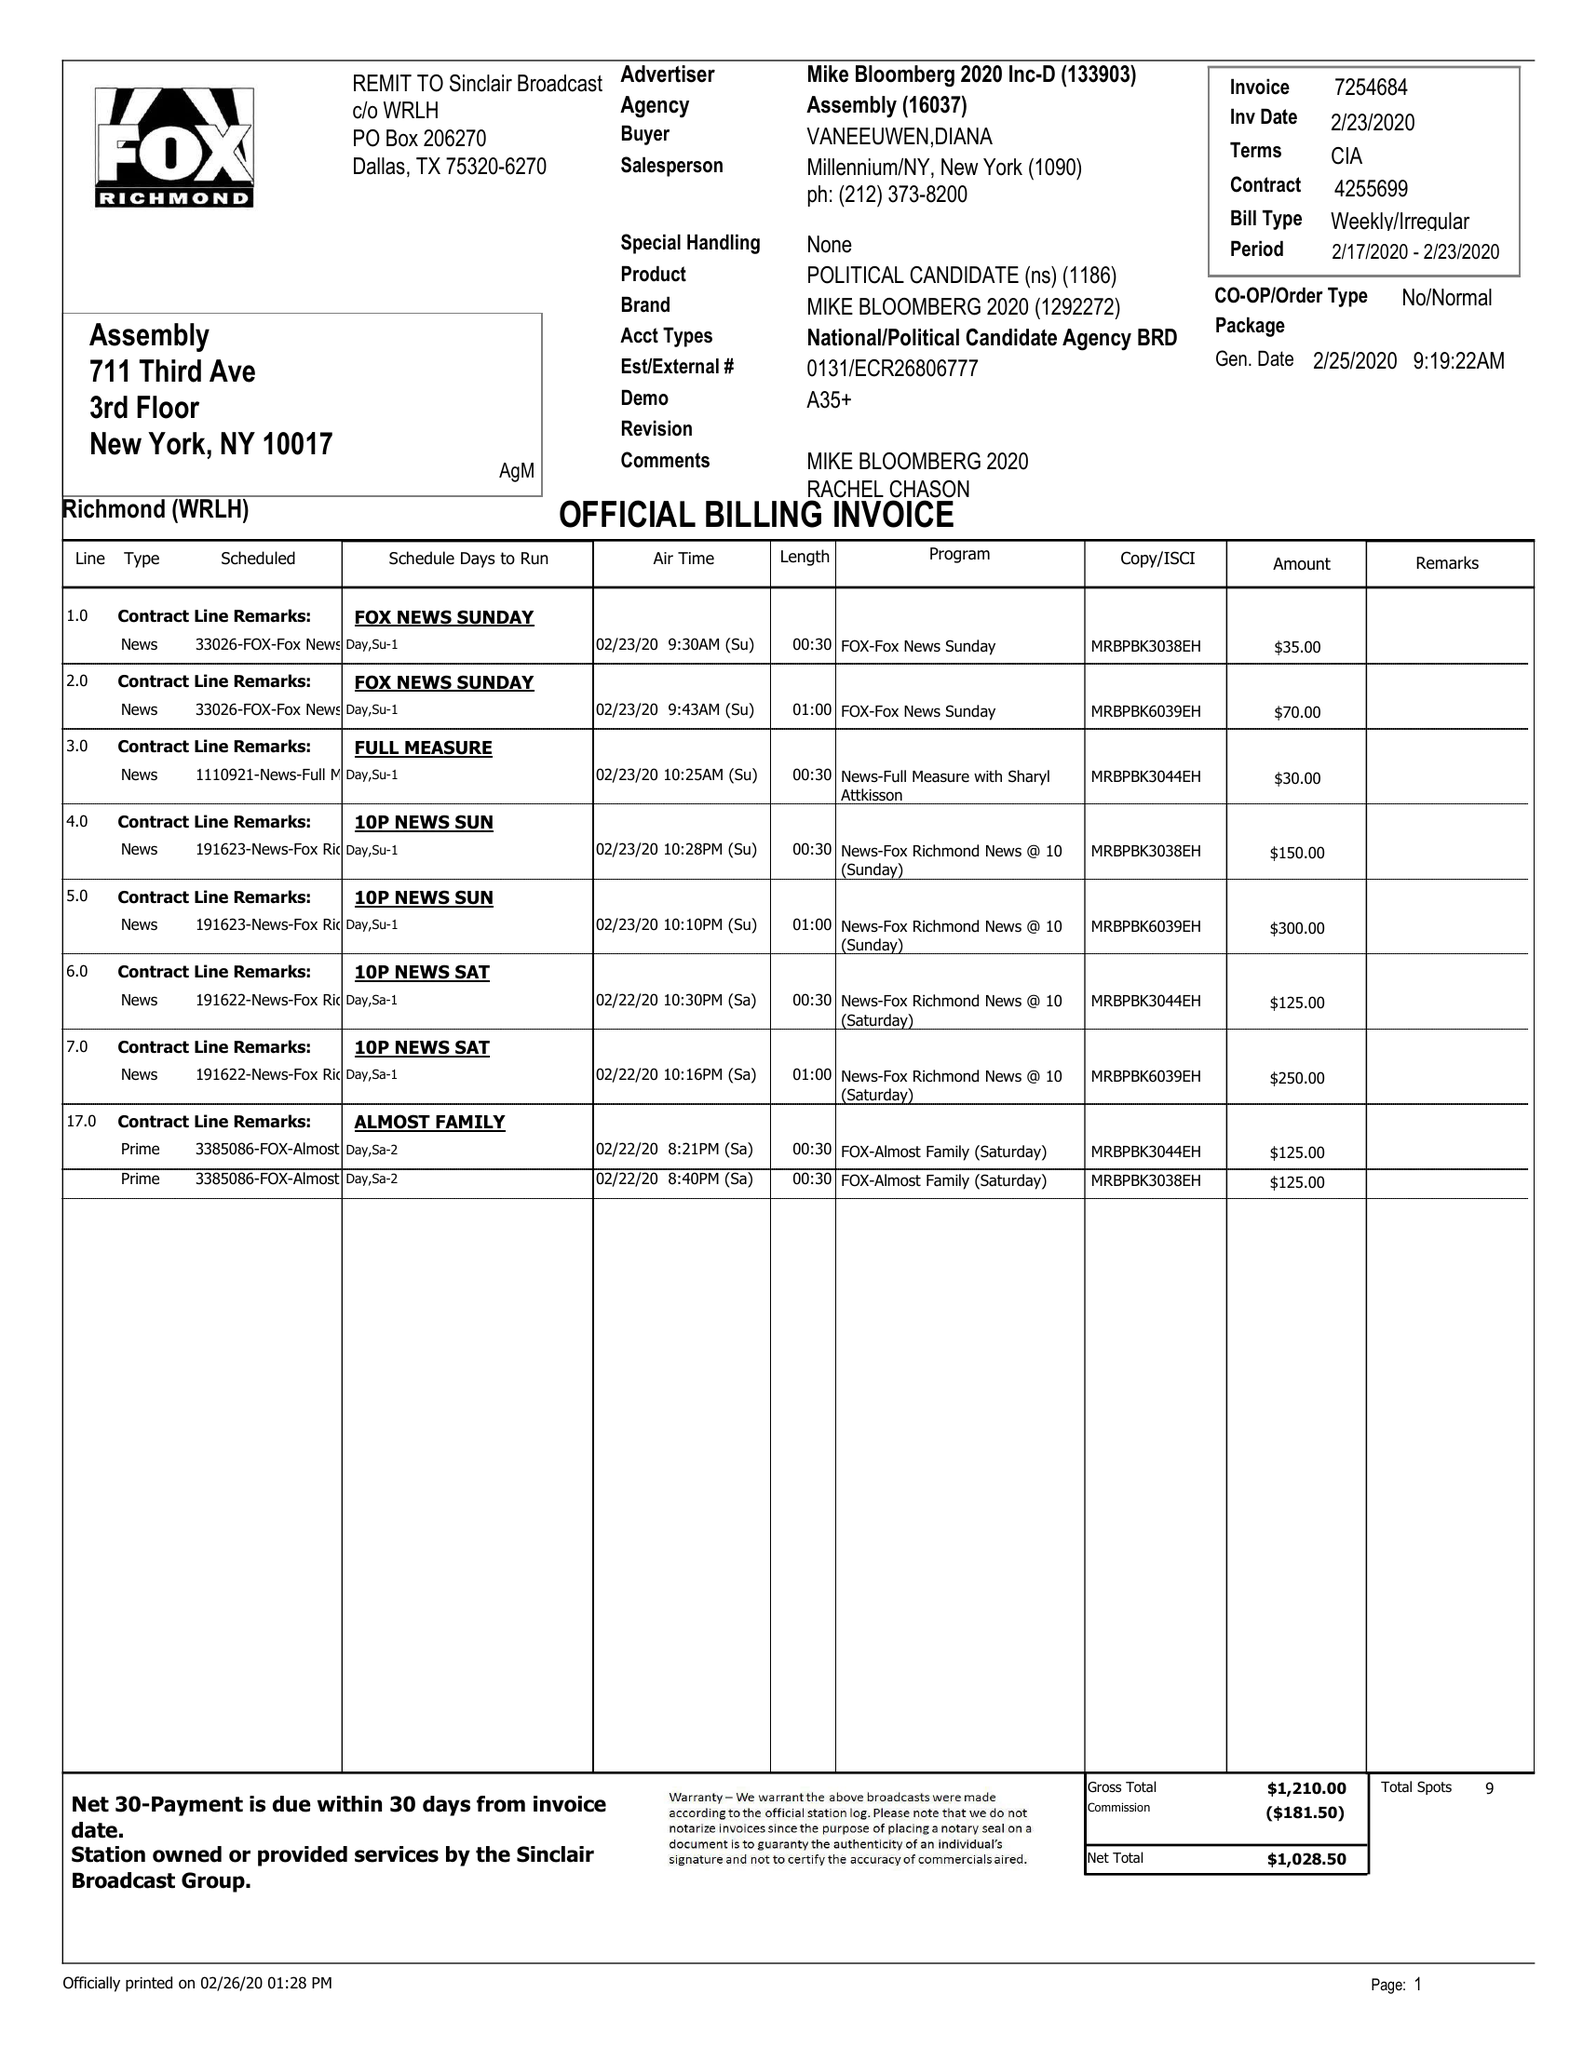What is the value for the flight_to?
Answer the question using a single word or phrase. 02/23/20 